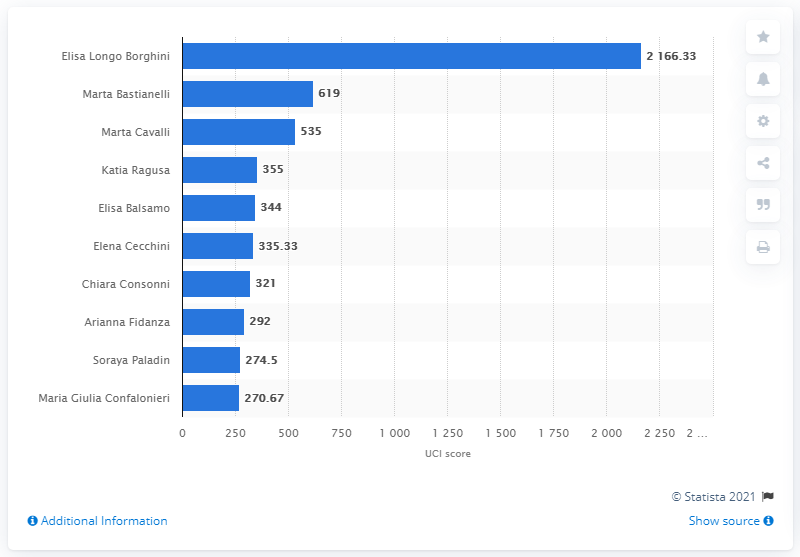List a handful of essential elements in this visual. Marta Bastianelli ranked 22nd worldwide in the UCI World Ranking, according to the most recent release of the ranking. Elisa Longo Borghini, an Italian cyclist, had the highest UCI score as of November 3, 2020. 